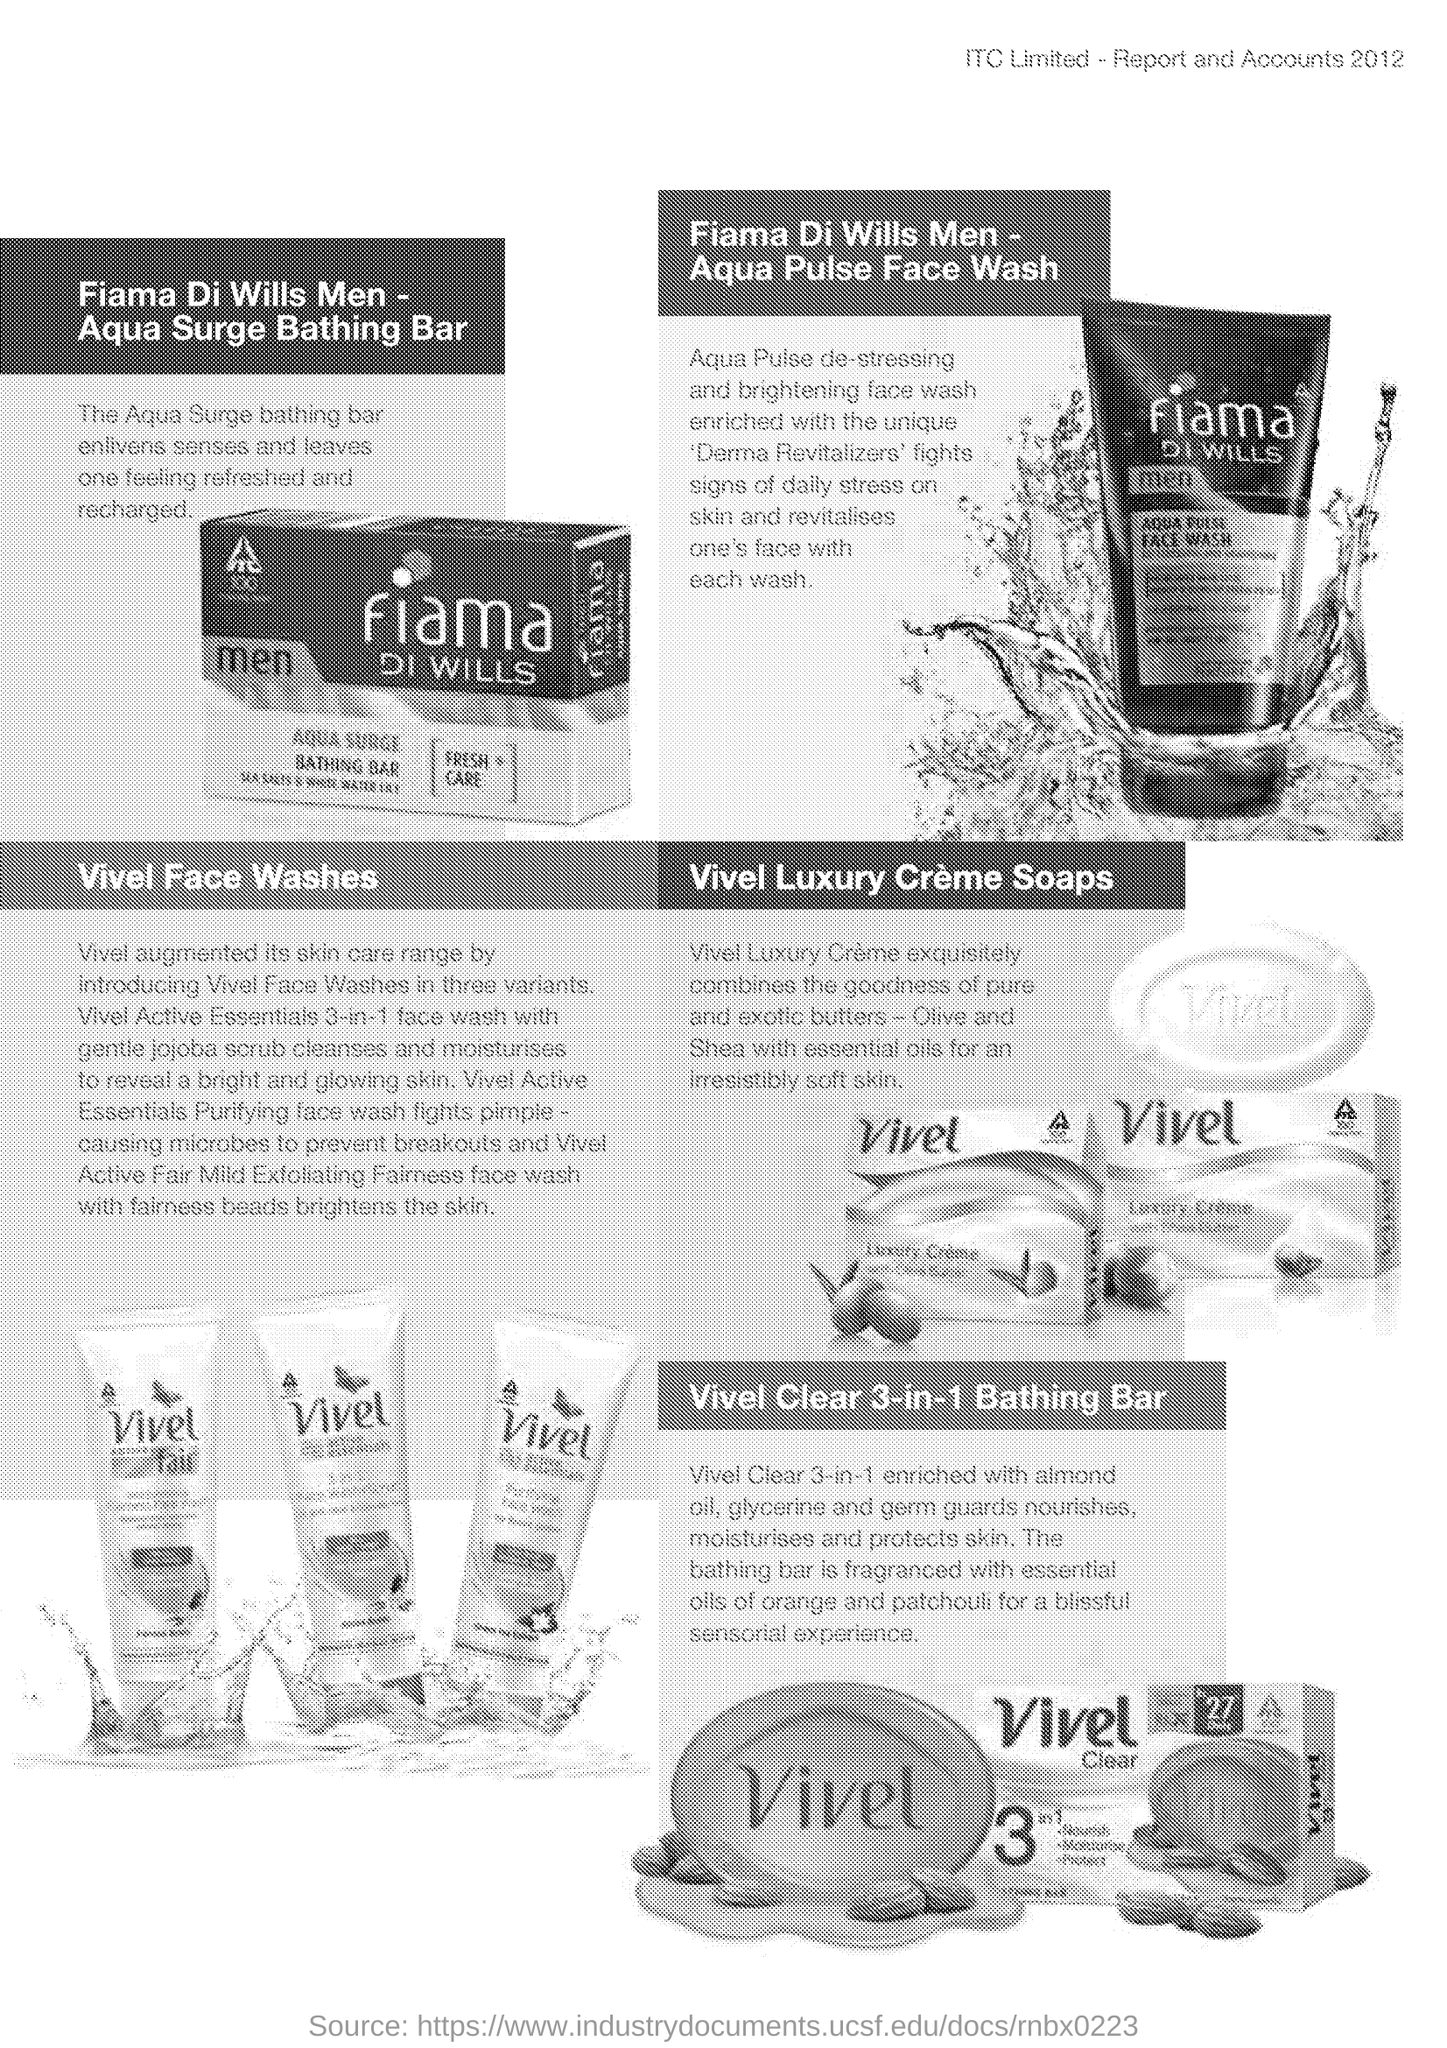Highlight a few significant elements in this photo. This Vivel Clear 3-in-1 Bathing Bar is fragranced with a unique combination of essential oils, including orange and patchouli, for a truly refreshing and rejuvenating experience. The capital letters within the company logo seen on the picture of the soap are ITC. The document is a report or account with a heading that mentions the year 2012. Vivel has expanded its skin care portfolio by introducing three variants of its Face Wash products. Fiama Di Wills Men - Aqua Pulse Face Wash contains Derma Revitalizers that combat the visible effects of daily stress. 